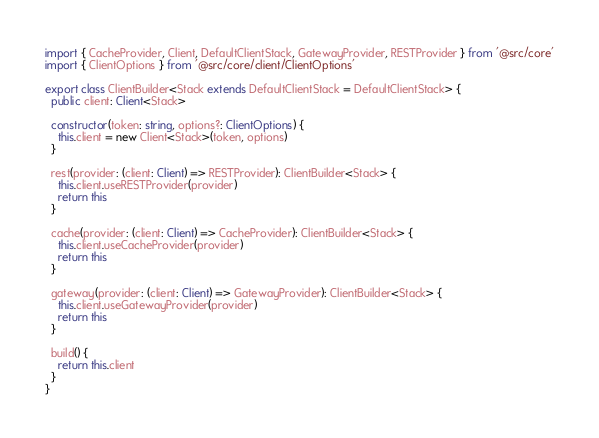<code> <loc_0><loc_0><loc_500><loc_500><_TypeScript_>import { CacheProvider, Client, DefaultClientStack, GatewayProvider, RESTProvider } from '@src/core'
import { ClientOptions } from '@src/core/client/ClientOptions'

export class ClientBuilder<Stack extends DefaultClientStack = DefaultClientStack> {
  public client: Client<Stack>

  constructor(token: string, options?: ClientOptions) {
    this.client = new Client<Stack>(token, options)
  }

  rest(provider: (client: Client) => RESTProvider): ClientBuilder<Stack> {
    this.client.useRESTProvider(provider)
    return this
  }

  cache(provider: (client: Client) => CacheProvider): ClientBuilder<Stack> {
    this.client.useCacheProvider(provider)
    return this
  }

  gateway(provider: (client: Client) => GatewayProvider): ClientBuilder<Stack> {
    this.client.useGatewayProvider(provider)
    return this
  }

  build() {
    return this.client
  }
}
</code> 